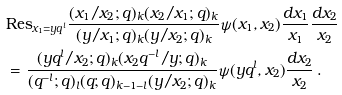Convert formula to latex. <formula><loc_0><loc_0><loc_500><loc_500>& \text {Res} _ { x _ { 1 } = y q ^ { l } } \frac { ( x _ { 1 } / x _ { 2 } ; q ) _ { k } ( x _ { 2 } / x _ { 1 } ; q ) _ { k } } { ( y / x _ { 1 } ; q ) _ { k } ( y / x _ { 2 } ; q ) _ { k } } \psi ( x _ { 1 } , x _ { 2 } ) \frac { d x _ { 1 } } { x _ { 1 } } \frac { d x _ { 2 } } { x _ { 2 } } \\ & = \frac { ( { y q ^ { l } } / { x _ { 2 } } ; q ) _ { k } ( { x _ { 2 } q ^ { - l } } / y ; q ) _ { k } } { ( q ^ { - l } ; q ) _ { l } ( q ; q ) _ { k - 1 - l } ( y / x _ { 2 } ; q ) _ { k } } \psi ( y q ^ { l } , x _ { 2 } ) \frac { d x _ { 2 } } { x _ { 2 } } \, .</formula> 